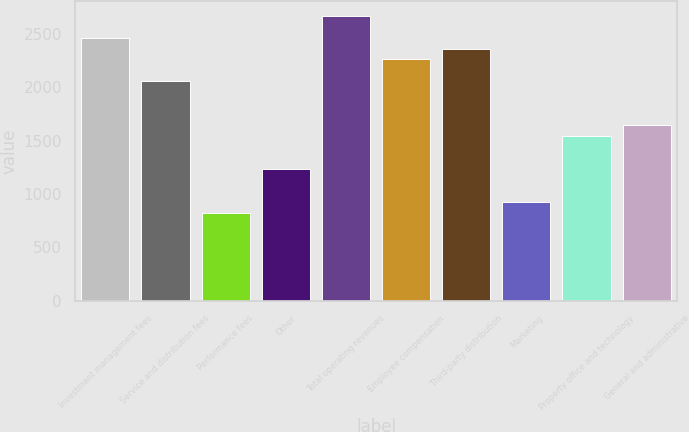Convert chart. <chart><loc_0><loc_0><loc_500><loc_500><bar_chart><fcel>Investment management fees<fcel>Service and distribution fees<fcel>Performance fees<fcel>Other<fcel>Total operating revenues<fcel>Employee compensation<fcel>Third-party distribution<fcel>Marketing<fcel>Property office and technology<fcel>General and administrative<nl><fcel>2468.27<fcel>2056.91<fcel>822.83<fcel>1234.19<fcel>2673.95<fcel>2262.59<fcel>2365.43<fcel>925.67<fcel>1542.71<fcel>1645.55<nl></chart> 